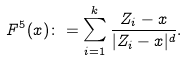<formula> <loc_0><loc_0><loc_500><loc_500>F ^ { 5 } ( x ) \colon = \sum _ { i = 1 } ^ { k } \frac { Z _ { i } - x } { | Z _ { i } - x | ^ { d } } .</formula> 